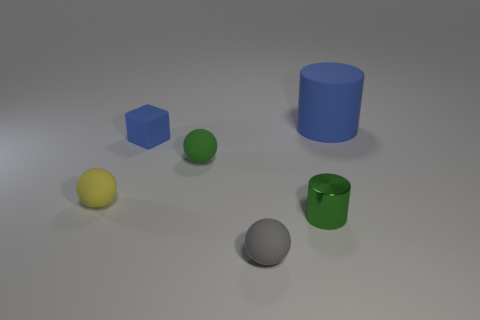What material is the yellow thing? The yellow object appears to be a sphere that could be made of rubber, which is a common material for spherical objects that look like balls. Its matte surface and slight shadowing suggest it could be used for recreational purposes, like a toy. 